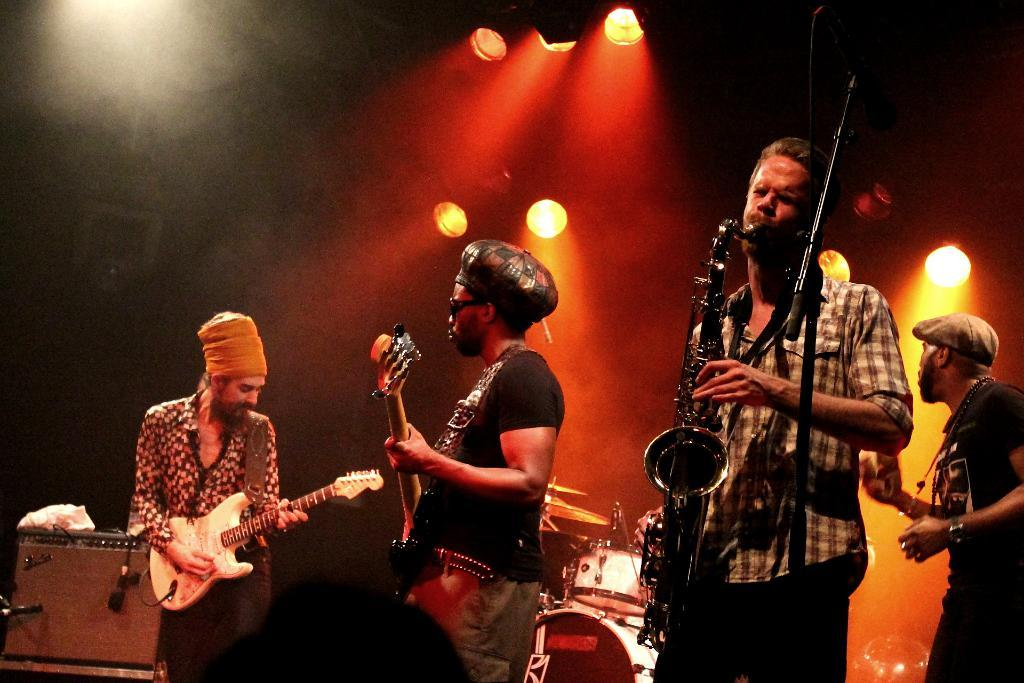What are the people in the image doing? Some of the people in the image are playing musical instruments. Are there any musical instruments visible besides the ones being played? Yes, there are musical instruments placed in the background. How is the scene in the image illuminated? The image shows light focusing on the scene. What condition is the doctor treating in the image? There is no doctor or medical condition present in the image; it features people playing musical instruments. How many attempts did it take for the people to successfully play their instruments in the image? The image does not show any attempts or progression; it captures a single moment in time. 